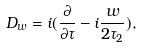<formula> <loc_0><loc_0><loc_500><loc_500>D _ { w } = i ( \frac { \partial } { \partial \tau } - i \frac { w } { 2 \tau _ { 2 } } ) ,</formula> 